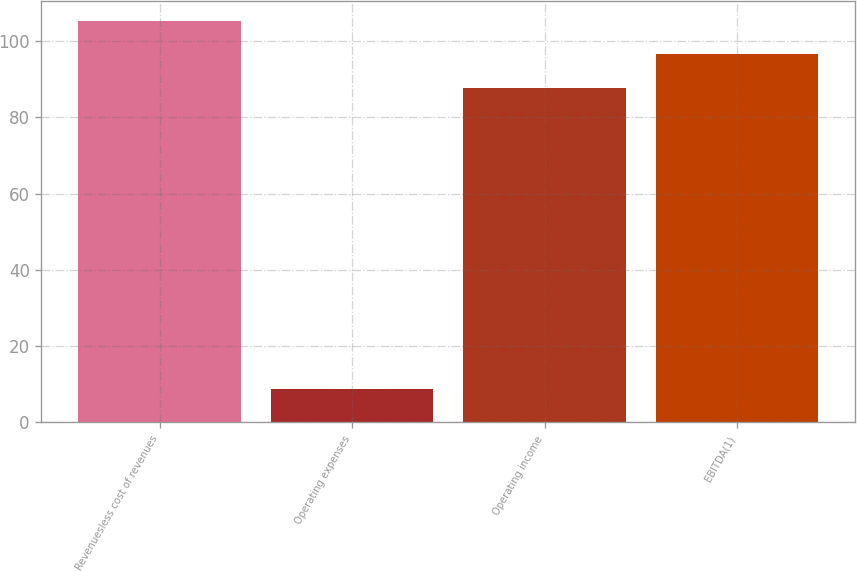Convert chart. <chart><loc_0><loc_0><loc_500><loc_500><bar_chart><fcel>Revenuesless cost of revenues<fcel>Operating expenses<fcel>Operating income<fcel>EBITDA(1)<nl><fcel>105.24<fcel>8.8<fcel>87.7<fcel>96.47<nl></chart> 